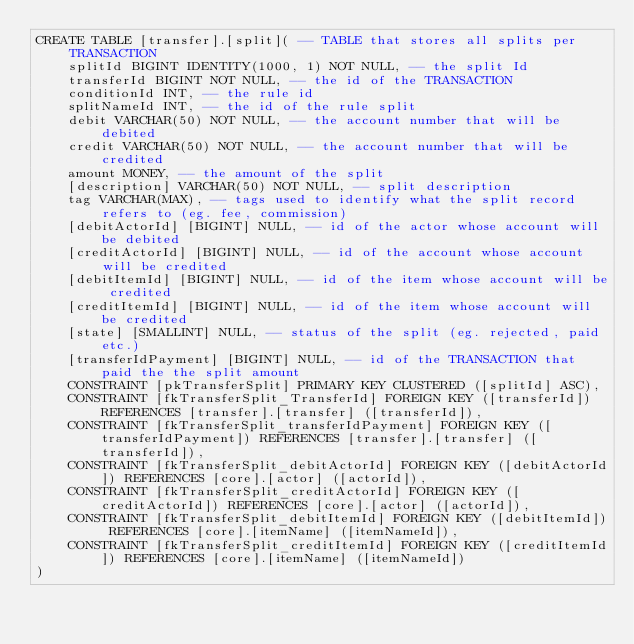<code> <loc_0><loc_0><loc_500><loc_500><_SQL_>CREATE TABLE [transfer].[split]( -- TABLE that stores all splits per TRANSACTION
    splitId BIGINT IDENTITY(1000, 1) NOT NULL, -- the split Id
    transferId BIGINT NOT NULL, -- the id of the TRANSACTION
    conditionId INT, -- the rule id
    splitNameId INT, -- the id of the rule split
    debit VARCHAR(50) NOT NULL, -- the account number that will be debited
    credit VARCHAR(50) NOT NULL, -- the account number that will be credited
    amount MONEY, -- the amount of the split
    [description] VARCHAR(50) NOT NULL, -- split description
    tag VARCHAR(MAX), -- tags used to identify what the split record refers to (eg. fee, commission)
    [debitActorId] [BIGINT] NULL, -- id of the actor whose account will be debited
    [creditActorId] [BIGINT] NULL, -- id of the account whose account will be credited
    [debitItemId] [BIGINT] NULL, -- id of the item whose account will be credited
    [creditItemId] [BIGINT] NULL, -- id of the item whose account will be credited
    [state] [SMALLINT] NULL, -- status of the split (eg. rejected, paid etc.)
    [transferIdPayment] [BIGINT] NULL, -- id of the TRANSACTION that paid the the split amount
    CONSTRAINT [pkTransferSplit] PRIMARY KEY CLUSTERED ([splitId] ASC),
    CONSTRAINT [fkTransferSplit_TransferId] FOREIGN KEY ([transferId]) REFERENCES [transfer].[transfer] ([transferId]),
    CONSTRAINT [fkTransferSplit_transferIdPayment] FOREIGN KEY ([transferIdPayment]) REFERENCES [transfer].[transfer] ([transferId]),
    CONSTRAINT [fkTransferSplit_debitActorId] FOREIGN KEY ([debitActorId]) REFERENCES [core].[actor] ([actorId]),
    CONSTRAINT [fkTransferSplit_creditActorId] FOREIGN KEY ([creditActorId]) REFERENCES [core].[actor] ([actorId]),
    CONSTRAINT [fkTransferSplit_debitItemId] FOREIGN KEY ([debitItemId]) REFERENCES [core].[itemName] ([itemNameId]),
    CONSTRAINT [fkTransferSplit_creditItemId] FOREIGN KEY ([creditItemId]) REFERENCES [core].[itemName] ([itemNameId])
)
</code> 